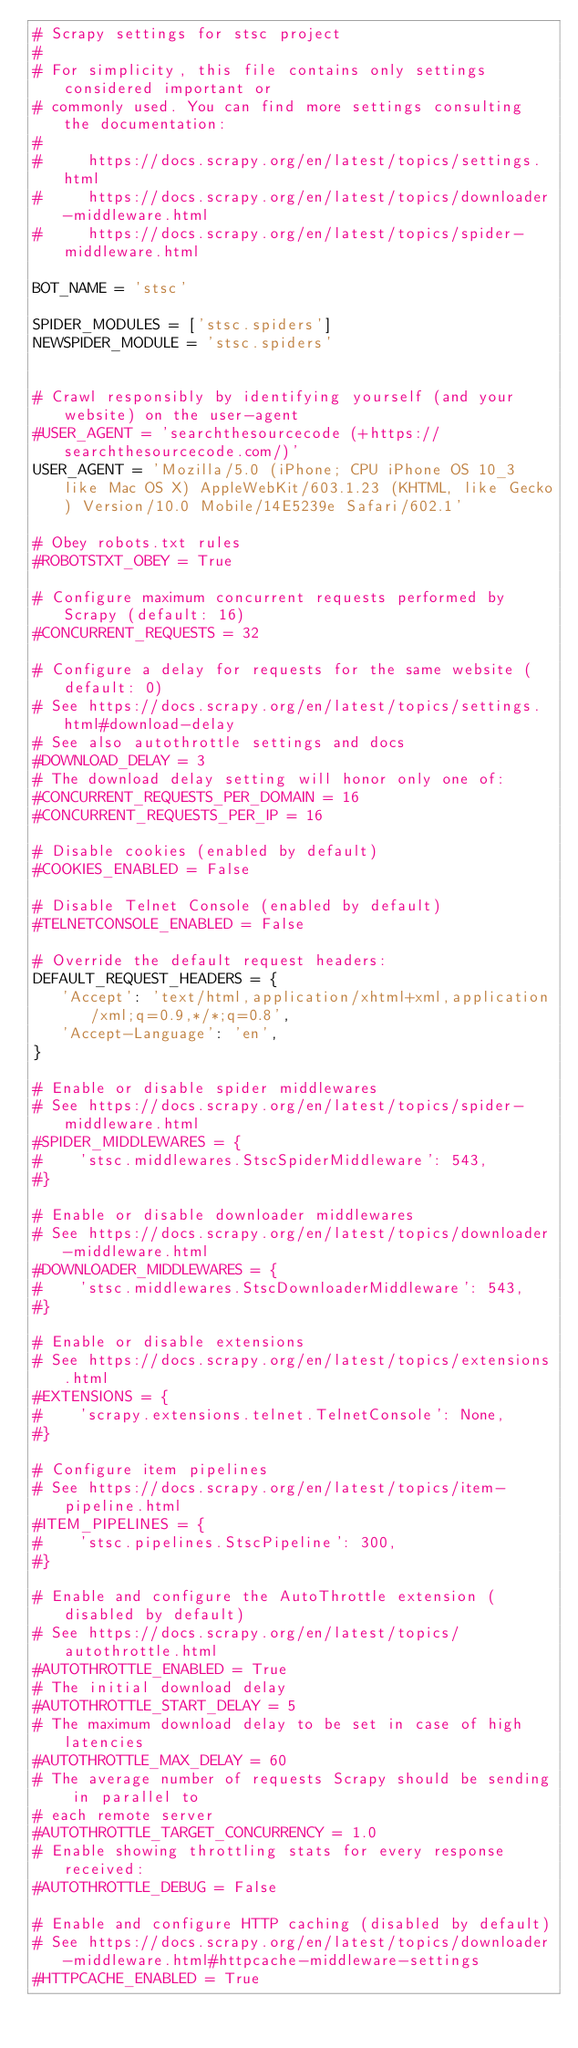Convert code to text. <code><loc_0><loc_0><loc_500><loc_500><_Python_># Scrapy settings for stsc project
#
# For simplicity, this file contains only settings considered important or
# commonly used. You can find more settings consulting the documentation:
#
#     https://docs.scrapy.org/en/latest/topics/settings.html
#     https://docs.scrapy.org/en/latest/topics/downloader-middleware.html
#     https://docs.scrapy.org/en/latest/topics/spider-middleware.html

BOT_NAME = 'stsc'

SPIDER_MODULES = ['stsc.spiders']
NEWSPIDER_MODULE = 'stsc.spiders'


# Crawl responsibly by identifying yourself (and your website) on the user-agent
#USER_AGENT = 'searchthesourcecode (+https://searchthesourcecode.com/)'
USER_AGENT = 'Mozilla/5.0 (iPhone; CPU iPhone OS 10_3 like Mac OS X) AppleWebKit/603.1.23 (KHTML, like Gecko) Version/10.0 Mobile/14E5239e Safari/602.1'

# Obey robots.txt rules
#ROBOTSTXT_OBEY = True

# Configure maximum concurrent requests performed by Scrapy (default: 16)
#CONCURRENT_REQUESTS = 32

# Configure a delay for requests for the same website (default: 0)
# See https://docs.scrapy.org/en/latest/topics/settings.html#download-delay
# See also autothrottle settings and docs
#DOWNLOAD_DELAY = 3
# The download delay setting will honor only one of:
#CONCURRENT_REQUESTS_PER_DOMAIN = 16
#CONCURRENT_REQUESTS_PER_IP = 16

# Disable cookies (enabled by default)
#COOKIES_ENABLED = False

# Disable Telnet Console (enabled by default)
#TELNETCONSOLE_ENABLED = False

# Override the default request headers:
DEFAULT_REQUEST_HEADERS = {
   'Accept': 'text/html,application/xhtml+xml,application/xml;q=0.9,*/*;q=0.8',
   'Accept-Language': 'en',
}

# Enable or disable spider middlewares
# See https://docs.scrapy.org/en/latest/topics/spider-middleware.html
#SPIDER_MIDDLEWARES = {
#    'stsc.middlewares.StscSpiderMiddleware': 543,
#}

# Enable or disable downloader middlewares
# See https://docs.scrapy.org/en/latest/topics/downloader-middleware.html
#DOWNLOADER_MIDDLEWARES = {
#    'stsc.middlewares.StscDownloaderMiddleware': 543,
#}

# Enable or disable extensions
# See https://docs.scrapy.org/en/latest/topics/extensions.html
#EXTENSIONS = {
#    'scrapy.extensions.telnet.TelnetConsole': None,
#}

# Configure item pipelines
# See https://docs.scrapy.org/en/latest/topics/item-pipeline.html
#ITEM_PIPELINES = {
#    'stsc.pipelines.StscPipeline': 300,
#}

# Enable and configure the AutoThrottle extension (disabled by default)
# See https://docs.scrapy.org/en/latest/topics/autothrottle.html
#AUTOTHROTTLE_ENABLED = True
# The initial download delay
#AUTOTHROTTLE_START_DELAY = 5
# The maximum download delay to be set in case of high latencies
#AUTOTHROTTLE_MAX_DELAY = 60
# The average number of requests Scrapy should be sending in parallel to
# each remote server
#AUTOTHROTTLE_TARGET_CONCURRENCY = 1.0
# Enable showing throttling stats for every response received:
#AUTOTHROTTLE_DEBUG = False

# Enable and configure HTTP caching (disabled by default)
# See https://docs.scrapy.org/en/latest/topics/downloader-middleware.html#httpcache-middleware-settings
#HTTPCACHE_ENABLED = True</code> 